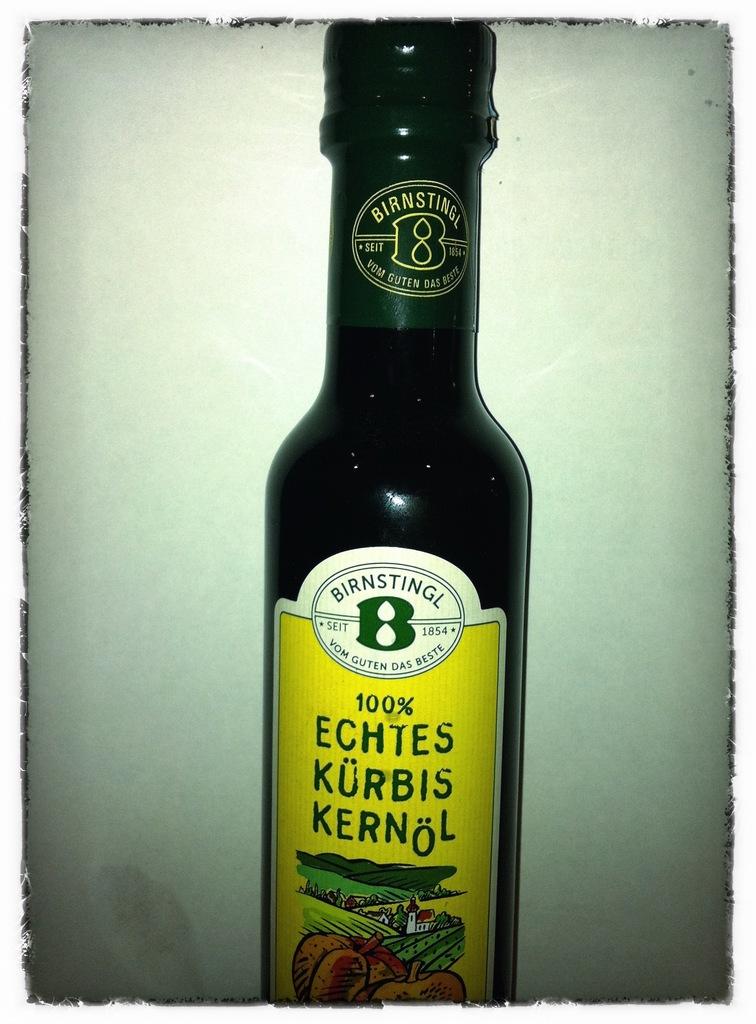What percent is the bottle?
Your response must be concise. 100. 